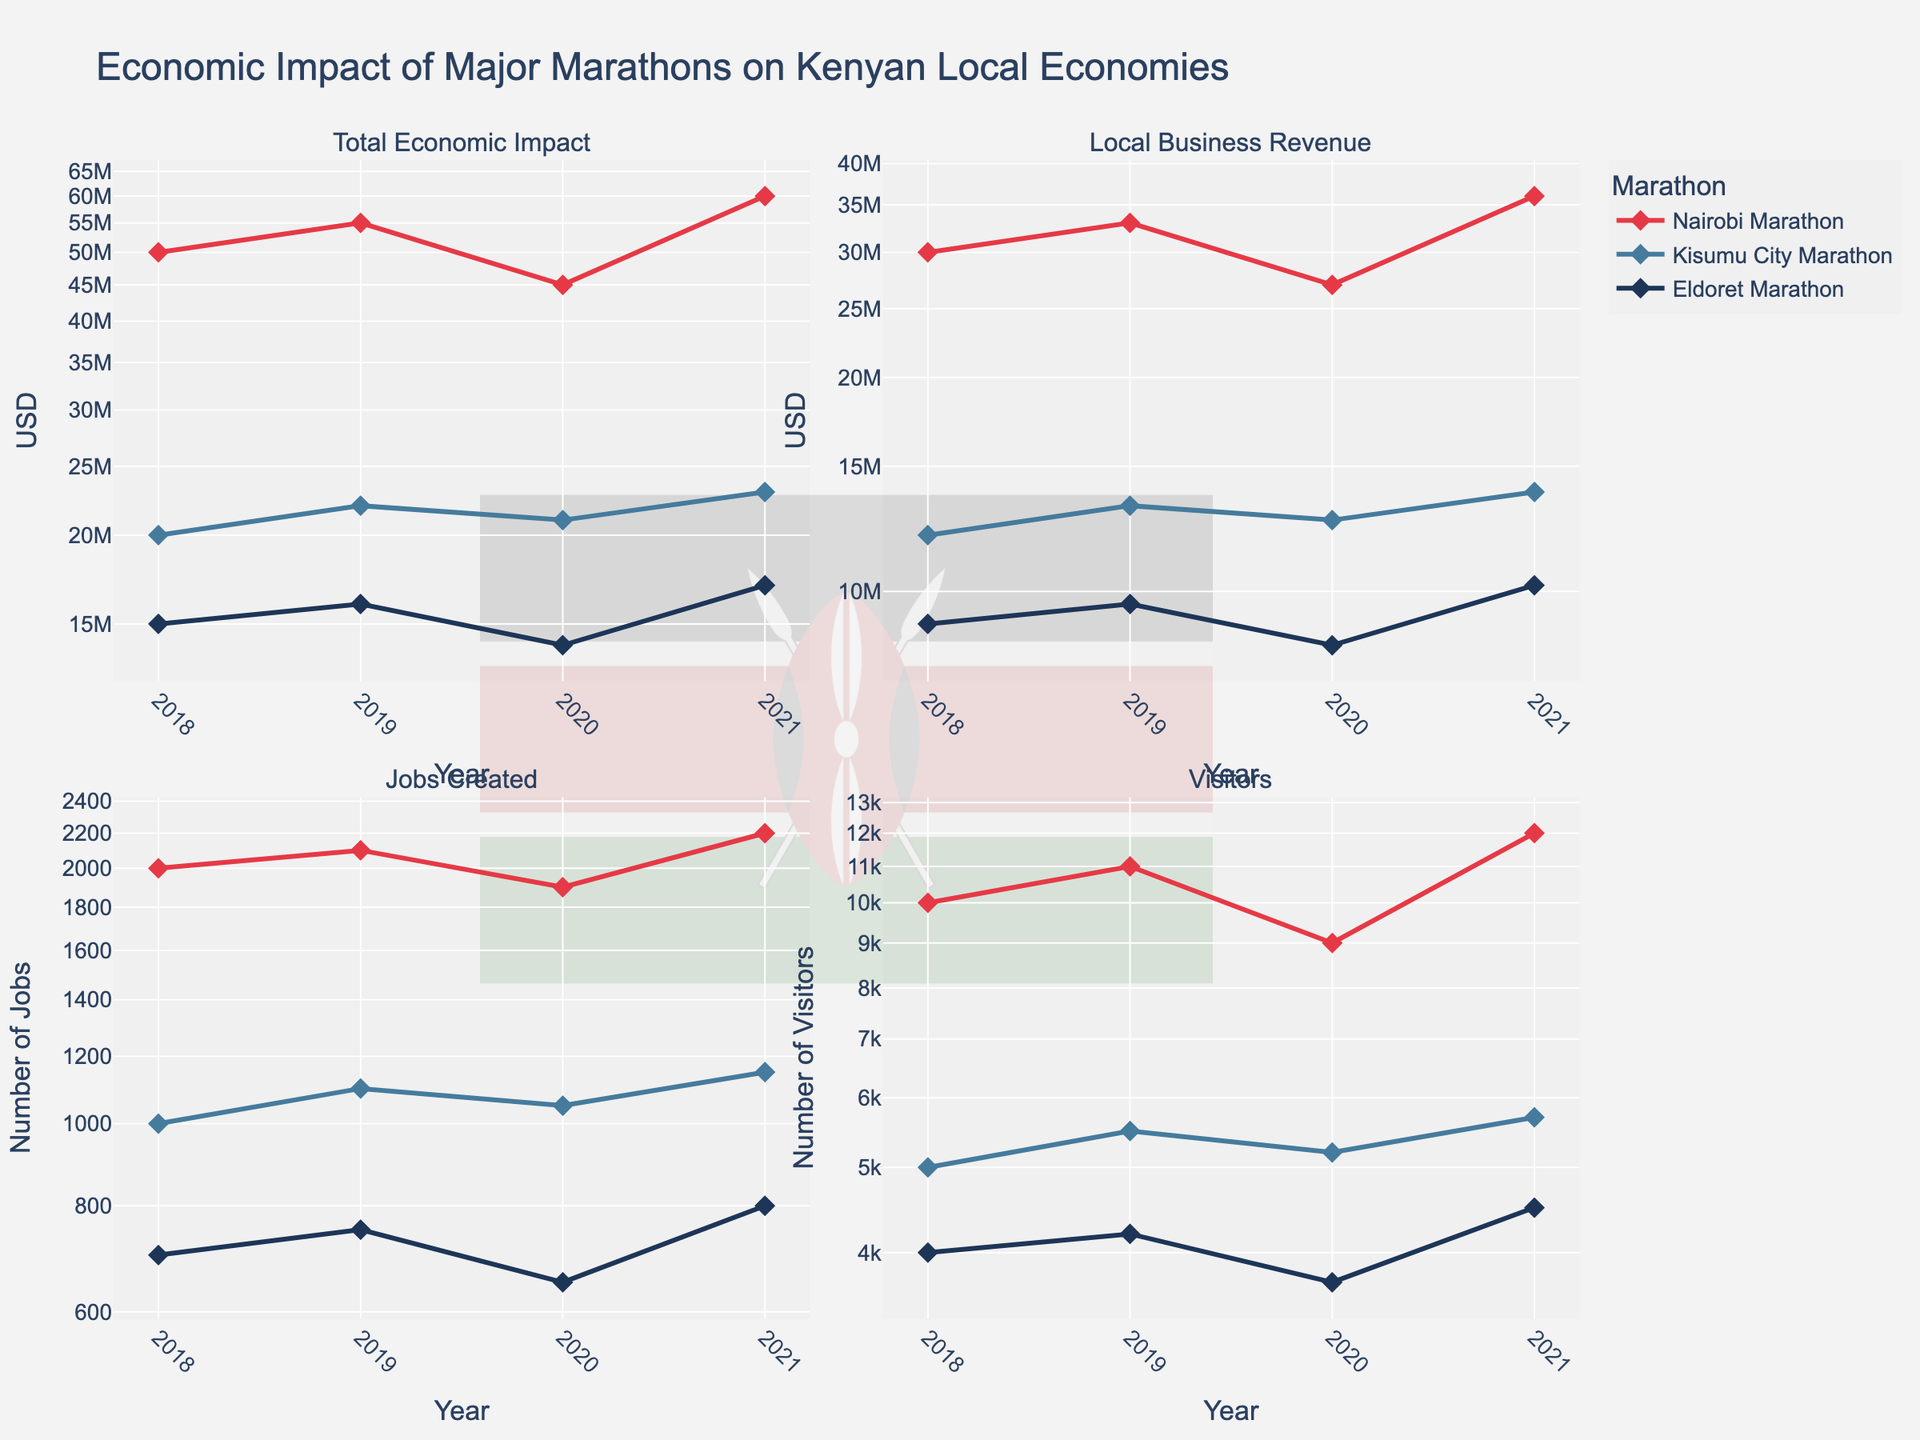What title is displayed at the top of the figure? The title is usually prominently displayed at the top of the chart. It helps to quickly understand the subject of the figure.
Answer: "Economic Impact of Major Marathons on Kenyan Local Economies" Which marathon had the highest Total Economic Impact in 2021? To answer this, look at the "Total Economic Impact" plot for the year 2021 and find the highest value among the marathons.
Answer: Nairobi Marathon What is the log scale used on the y-axis for "Local Business Revenue"? A log scale is indicated by evenly spaced ticks representing exponential growth. The y-axis for "Local Business Revenue" is marked with such a scale.
Answer: Logarithmic scale How did the number of visitors to the Kisumu City Marathon change from 2018 to 2021? Examine the subplot for "Visitors", locate the data points for Kisumu City Marathon for 2018 and 2021, and compare their values.
Answer: Increased from 5,000 to 5,700 What was the average number of jobs created by the Eldoret Marathon from 2018 to 2021? Identify all data points for the Eldoret Marathon in the "Jobs Created" subplot. Sum the values, then divide by the number of years (4). (700 + 750 + 650 + 800) / 4 = 725
Answer: 725 Which marathon showed the least increase in Local Business Revenue from 2018 to 2021? Observe the plots for "Local Business Revenue" and track the changes across years for all three marathons. Determine which one has the smallest overall increase.
Answer: Eldoret Marathon How does the Total Economic Impact in 2019 compare between the Nairobi Marathon and Kisumu City Marathon? Look at the "Total Economic Impact" subplot for the year 2019 and compare the economic impact values for Nairobi and Kisumu City Marathons.
Answer: Nairobi Marathon is significantly higher If the trend continued, which marathon's Total Economic Impact would you predict to be the highest in 2022? Evaluate the trends for each marathon in the "Total Economic Impact" subplot up to 2021 and extrapolate to predict for 2022.
Answer: Nairobi Marathon What are the colors used to represent the different marathons in the plot? Identify the distinct colors used in the subplots to depict each marathon.
Answer: Nairobi Marathon is red, Kisumu City Marathon is blue, Eldoret Marathon is dark blue Comparing 2020 and 2021, which marathon had the biggest growth in the number of jobs created? Find the difference in job creation between 2020 and 2021 for each marathon in the "Jobs Created" subplot and determine the largest increase.
Answer: Nairobi Marathon 